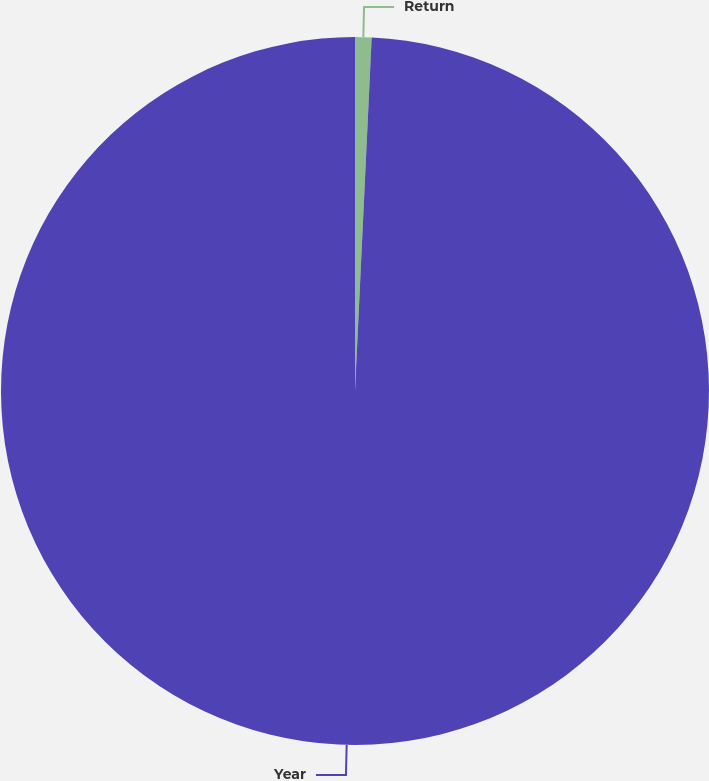Convert chart. <chart><loc_0><loc_0><loc_500><loc_500><pie_chart><fcel>Return<fcel>Year<nl><fcel>0.75%<fcel>99.25%<nl></chart> 